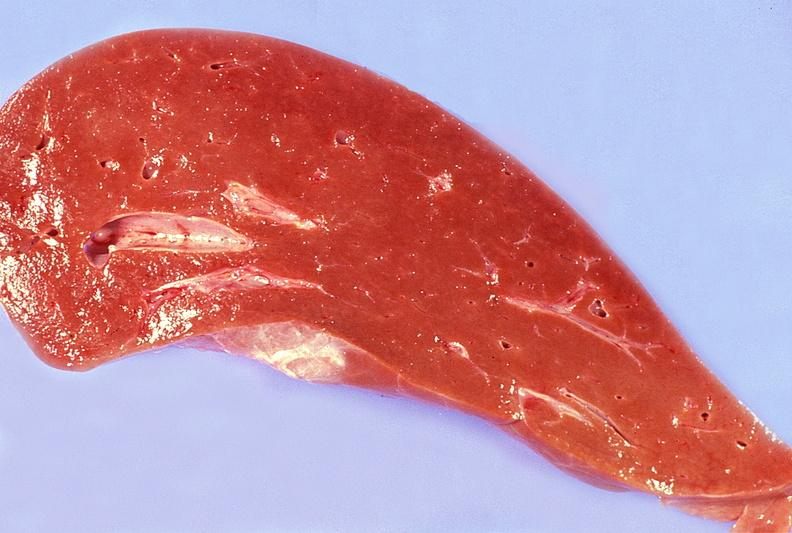what is present?
Answer the question using a single word or phrase. Hepatobiliary 